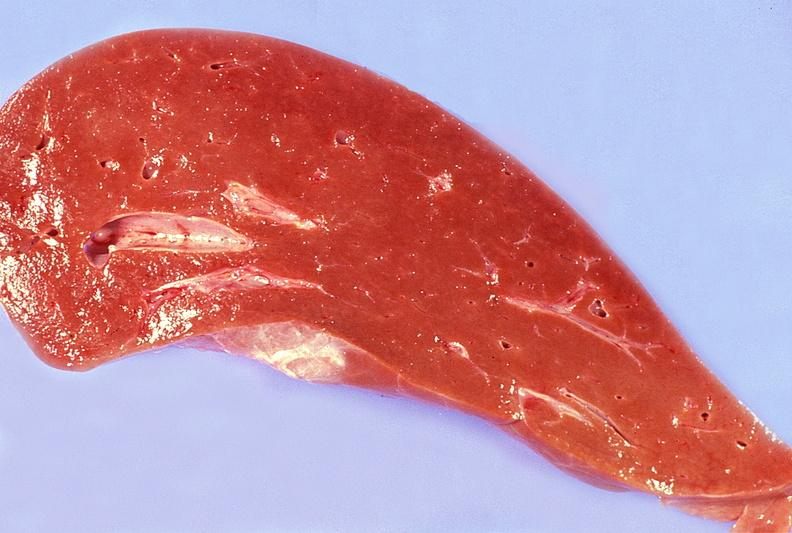what is present?
Answer the question using a single word or phrase. Hepatobiliary 